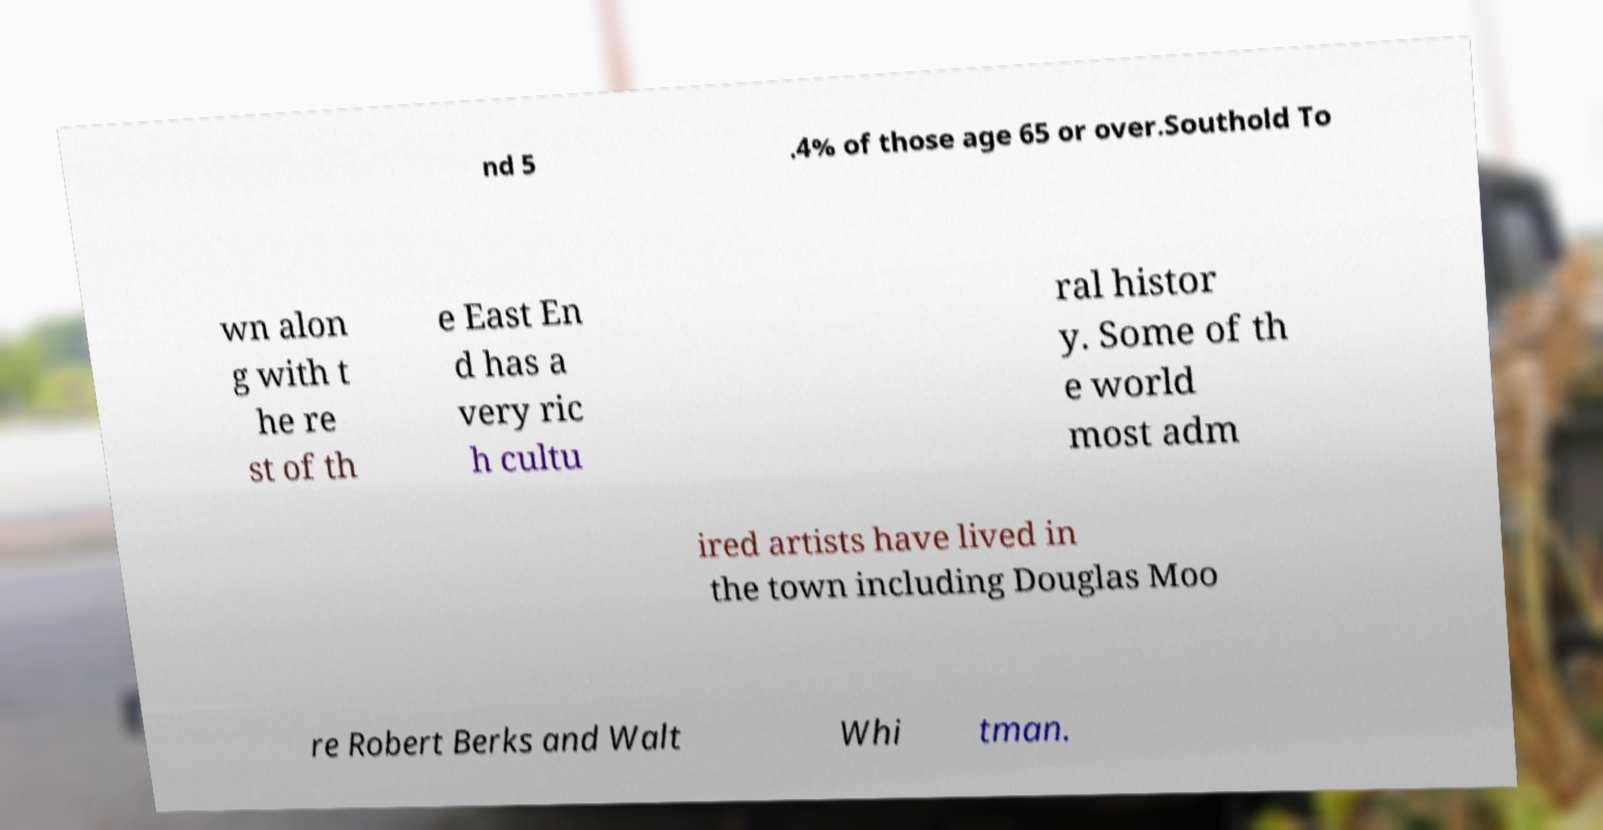Please identify and transcribe the text found in this image. nd 5 .4% of those age 65 or over.Southold To wn alon g with t he re st of th e East En d has a very ric h cultu ral histor y. Some of th e world most adm ired artists have lived in the town including Douglas Moo re Robert Berks and Walt Whi tman. 